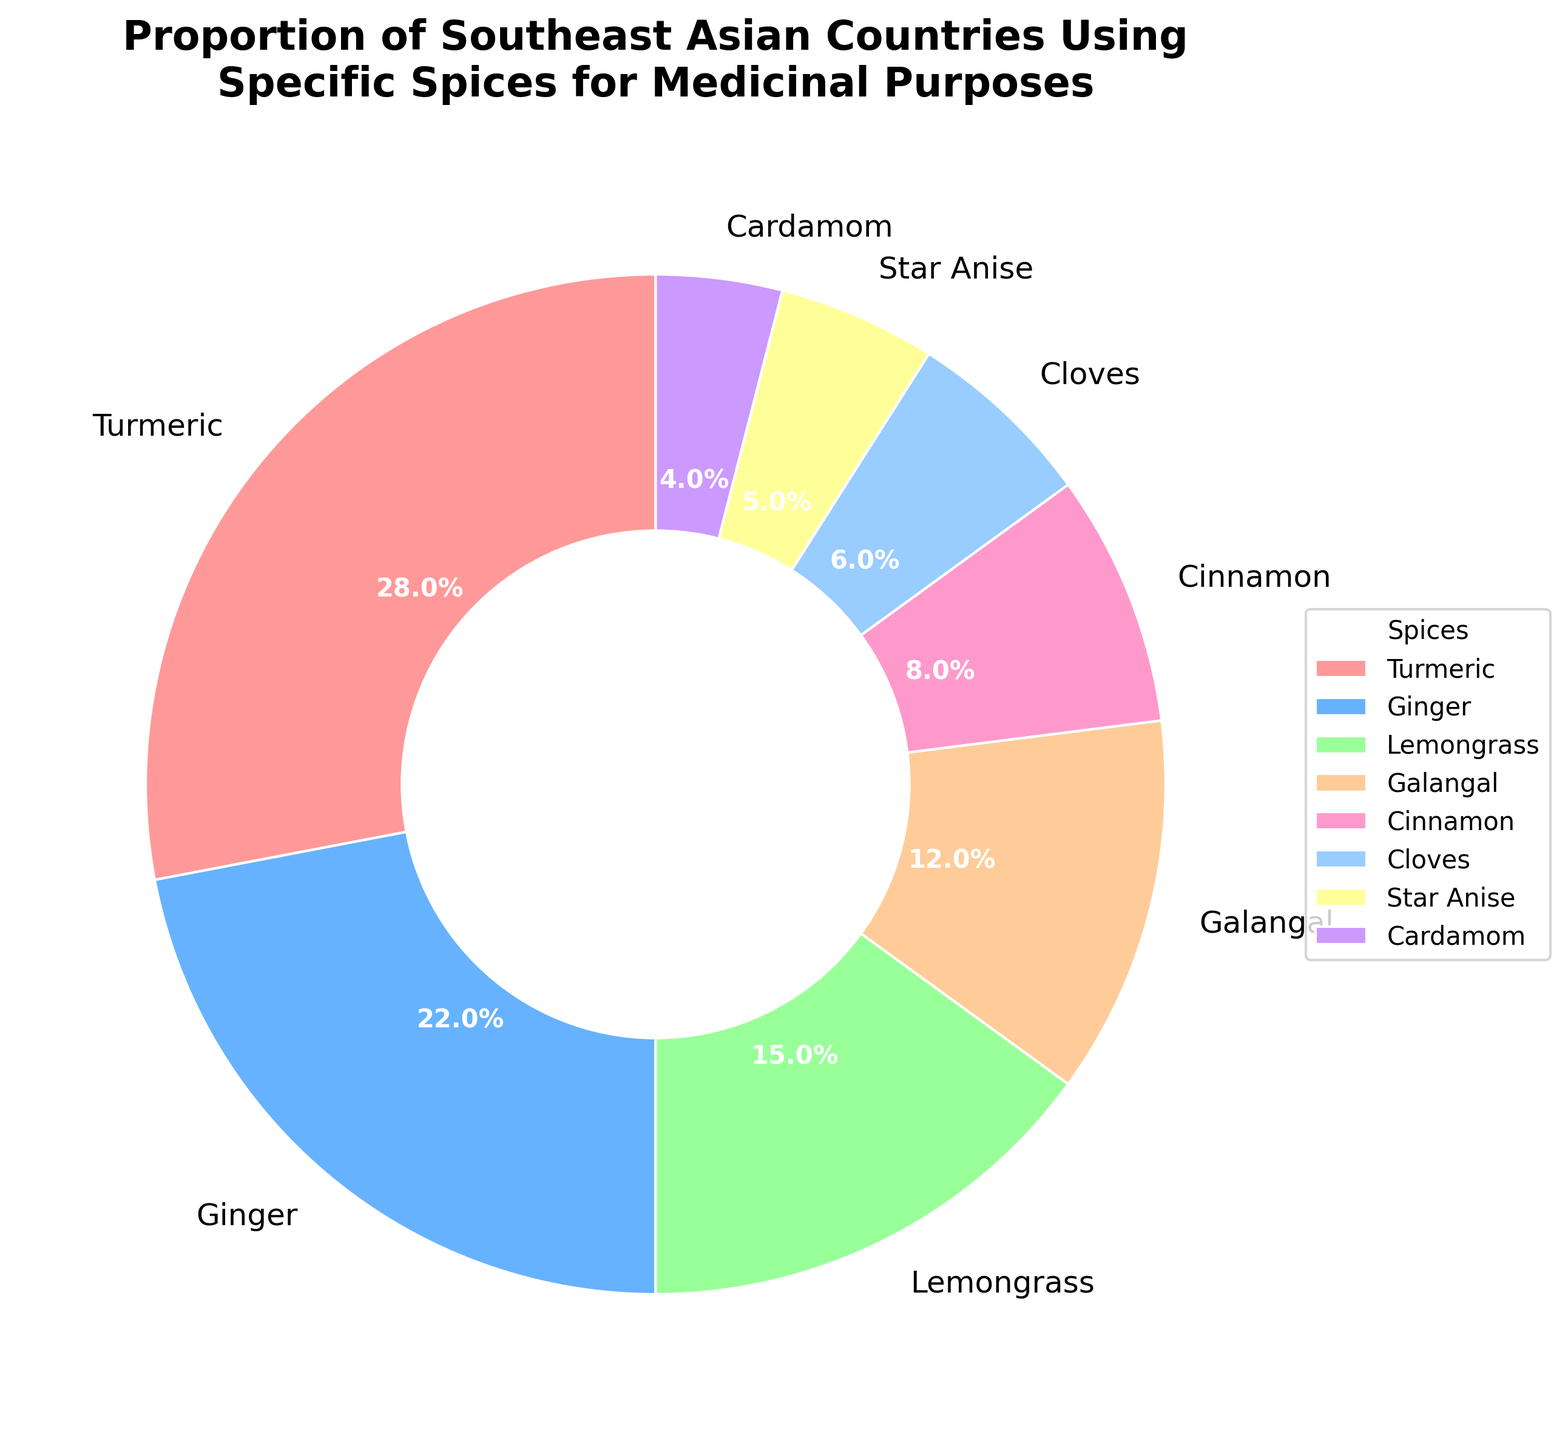Which spice has the highest proportion of usage for medicinal purposes? The largest slice of the pie chart represents the spice with the highest proportion. By examining the chart, you can see that Turmeric has the largest section.
Answer: Turmeric What is the combined percentage of Ginger and Lemongrass in medicinal usage? Locate the slices for Ginger and Lemongrass. Ginger is 22%, and Lemongrass is 15%. Add these two percentages together: 22% + 15% = 37%.
Answer: 37% Which spices have usage percentages under 10%? Any spice with less than a 10% section in the pie chart falls into this category. These spices are Cinnamon (8%), Cloves (6%), Star Anise (5%), and Cardamom (4%).
Answer: Cinnamon, Cloves, Star Anise, Cardamom How does the proportion of Galangal compare to that of Star Anise and Cardamom combined? Galangal has a proportion of 12%. Star Anise is 5%, and Cardamom is 4%. Combined, Star Anise and Cardamom have a proportion of 5% + 4% = 9%. Compare 12% (Galangal) to 9% (Star Anise + Cardamom).
Answer: Greater What percent more is the usage of Turmeric than the combined usage of Cloves and Star Anise? Turmeric's usage is 28%. Cloves and Star Anise are 6% and 5%, respectively, combining to 6% + 5% = 11%. The difference is 28% - 11% = 17%.
Answer: 17% What is the median usage percentage among all the spices listed? Arrange the percentages in ascending order: 4%, 5%, 6%, 8%, 12%, 15%, 22%, 28%. The median is the average of the 4th and 5th values (8% and 12%): (8% + 12%) / 2 = 10%.
Answer: 10% Which spice is represented by the orange color in the pie chart? The orange color typically represents a prominent section in the pie chart, and by looking at the colors, orange represents Turmeric.
Answer: Turmeric What is the difference between the highest and lowest usage percentages? Turmeric has the highest proportion (28%), and Cardamom has the lowest (4%). The difference is 28% - 4% = 24%.
Answer: 24% What is the average usage percentage for the spices represented in the pie chart? Sum all the percentages: 28% + 22% + 15% + 12% + 8% + 6% + 5% + 4% = 100%. There are 8 spices, so the average is 100% / 8 = 12.5%.
Answer: 12.5% 